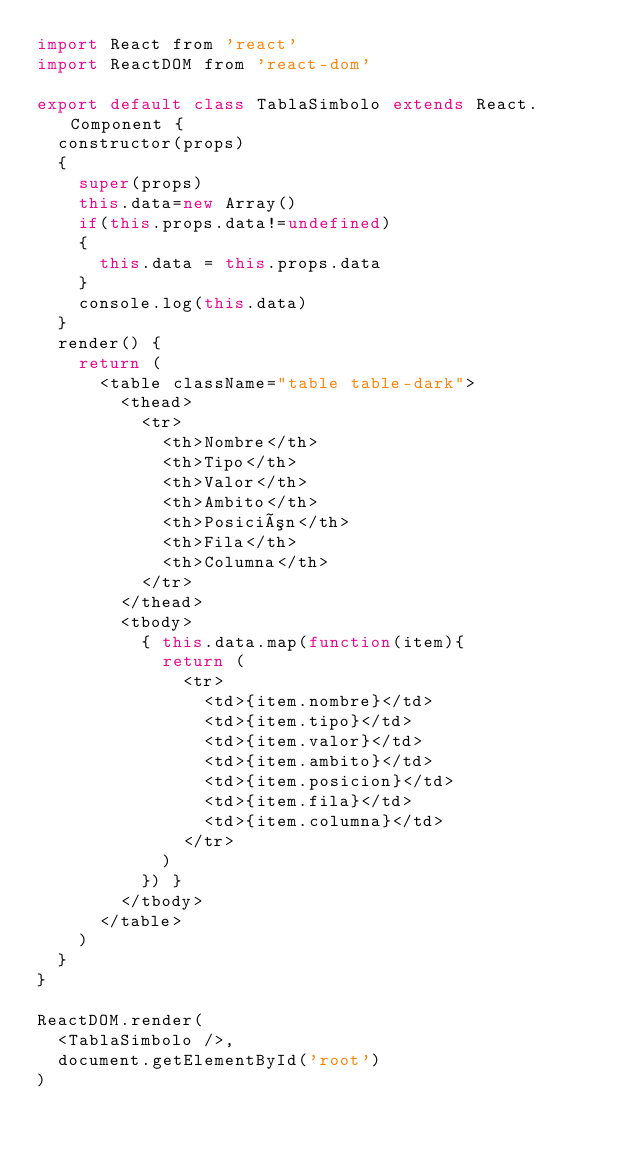Convert code to text. <code><loc_0><loc_0><loc_500><loc_500><_JavaScript_>import React from 'react'
import ReactDOM from 'react-dom'

export default class TablaSimbolo extends React.Component {
  constructor(props)
  {
    super(props)
    this.data=new Array()
    if(this.props.data!=undefined)
    {
      this.data = this.props.data
    }
    console.log(this.data)
  }
  render() {
    return (
      <table className="table table-dark"> 
        <thead> 
          <tr> 
            <th>Nombre</th> 
            <th>Tipo</th>
            <th>Valor</th>
            <th>Ambito</th> 
            <th>Posición</th>
            <th>Fila</th> 
            <th>Columna</th> 
          </tr> 
        </thead>
        <tbody>
          { this.data.map(function(item){
            return (
              <tr>
                <td>{item.nombre}</td>
                <td>{item.tipo}</td>
                <td>{item.valor}</td>
                <td>{item.ambito}</td>
                <td>{item.posicion}</td>
                <td>{item.fila}</td>
                <td>{item.columna}</td>
              </tr>
            )
          }) }
        </tbody> 
      </table>
    )
  }
}

ReactDOM.render(
  <TablaSimbolo />,
  document.getElementById('root')
)

</code> 